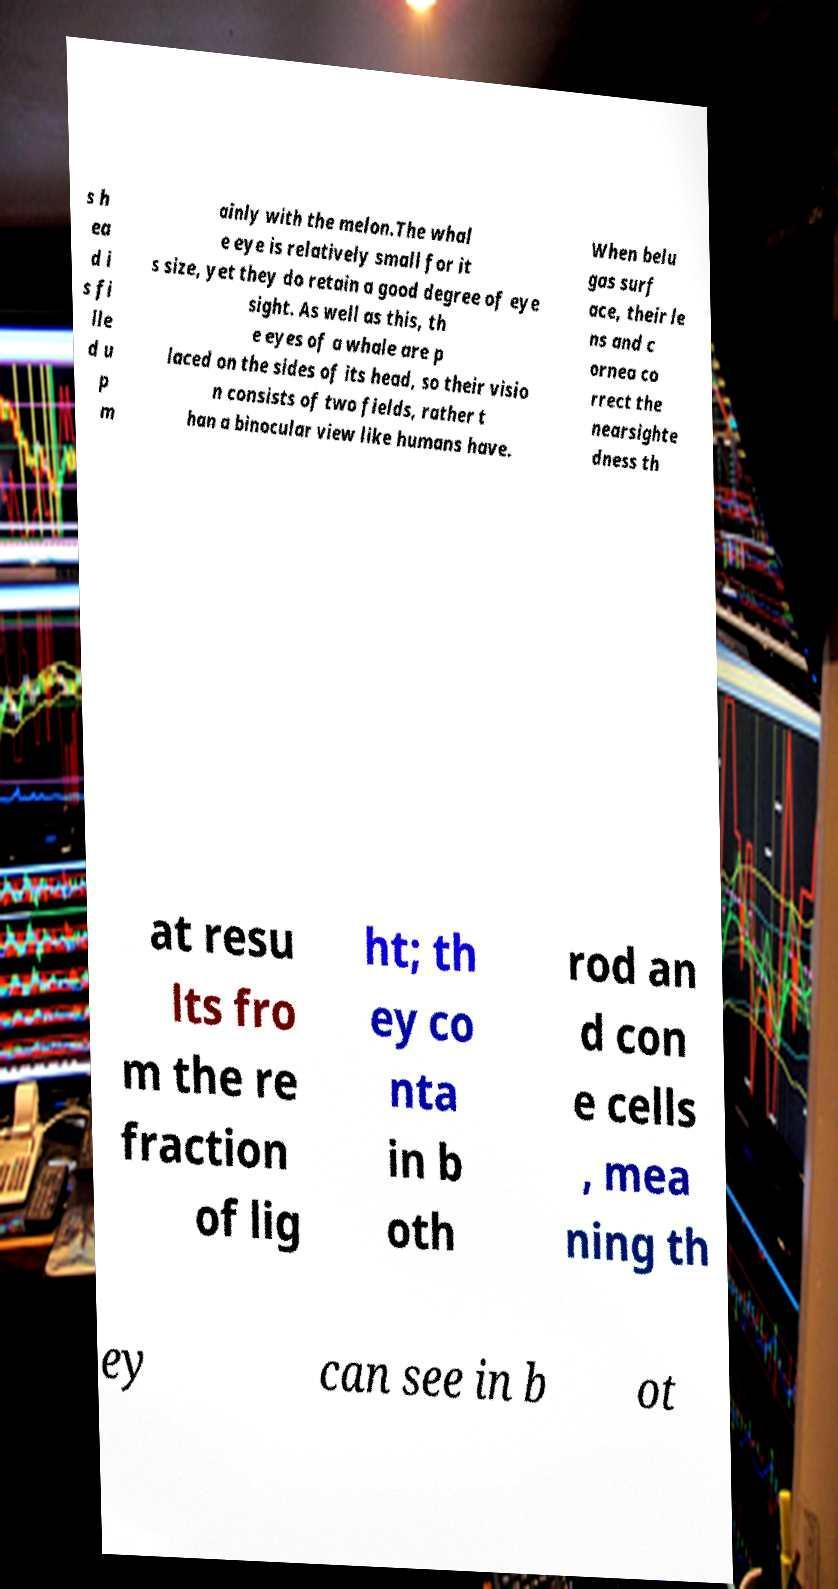What messages or text are displayed in this image? I need them in a readable, typed format. s h ea d i s fi lle d u p m ainly with the melon.The whal e eye is relatively small for it s size, yet they do retain a good degree of eye sight. As well as this, th e eyes of a whale are p laced on the sides of its head, so their visio n consists of two fields, rather t han a binocular view like humans have. When belu gas surf ace, their le ns and c ornea co rrect the nearsighte dness th at resu lts fro m the re fraction of lig ht; th ey co nta in b oth rod an d con e cells , mea ning th ey can see in b ot 